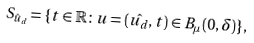Convert formula to latex. <formula><loc_0><loc_0><loc_500><loc_500>S _ { \hat { u } _ { d } } = \{ t \in \mathbb { R } \colon u = ( \hat { u _ { d } } , t ) \in B _ { \mu } ( 0 , \delta ) \} ,</formula> 